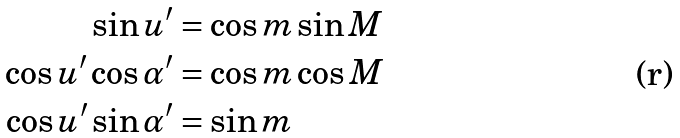Convert formula to latex. <formula><loc_0><loc_0><loc_500><loc_500>\sin u ^ { \prime } & = \cos m \sin M \\ \cos u ^ { \prime } \cos \alpha ^ { \prime } & = \cos m \cos M \\ \cos u ^ { \prime } \sin \alpha ^ { \prime } & = \sin m</formula> 